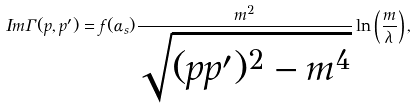<formula> <loc_0><loc_0><loc_500><loc_500>I m \Gamma ( p , p ^ { \prime } ) = f ( \alpha _ { s } ) \frac { m ^ { 2 } } { \sqrt { ( p p ^ { \prime } ) ^ { 2 } - m ^ { 4 } } } \ln \left ( \frac { m } { \lambda } \right ) ,</formula> 